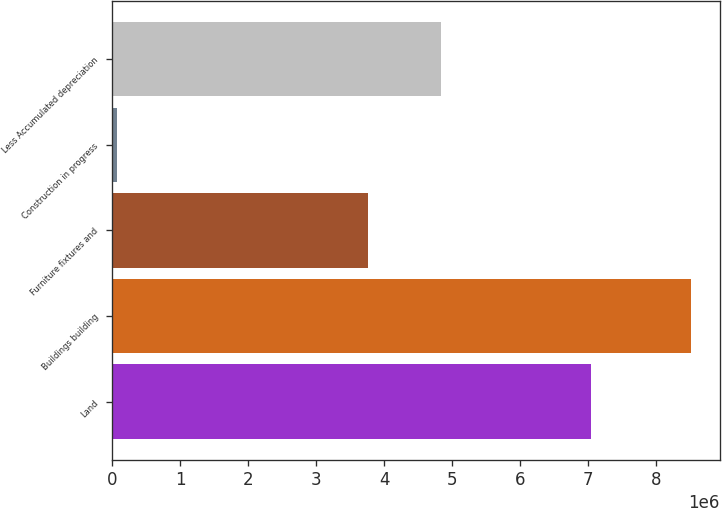Convert chart to OTSL. <chart><loc_0><loc_0><loc_500><loc_500><bar_chart><fcel>Land<fcel>Buildings building<fcel>Furniture fixtures and<fcel>Construction in progress<fcel>Less Accumulated depreciation<nl><fcel>7.03981e+06<fcel>8.50466e+06<fcel>3.76848e+06<fcel>72843<fcel>4.83143e+06<nl></chart> 